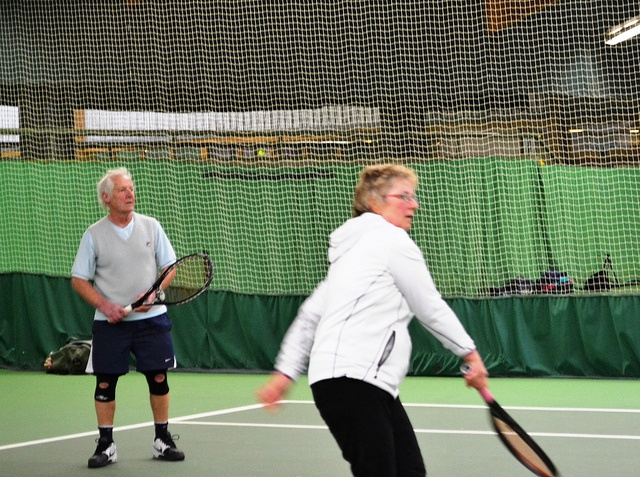Describe the objects in this image and their specific colors. I can see people in black, white, darkgray, and salmon tones, people in black, darkgray, lightgray, and brown tones, tennis racket in black, gray, darkgreen, and olive tones, and tennis racket in black, tan, gray, and brown tones in this image. 